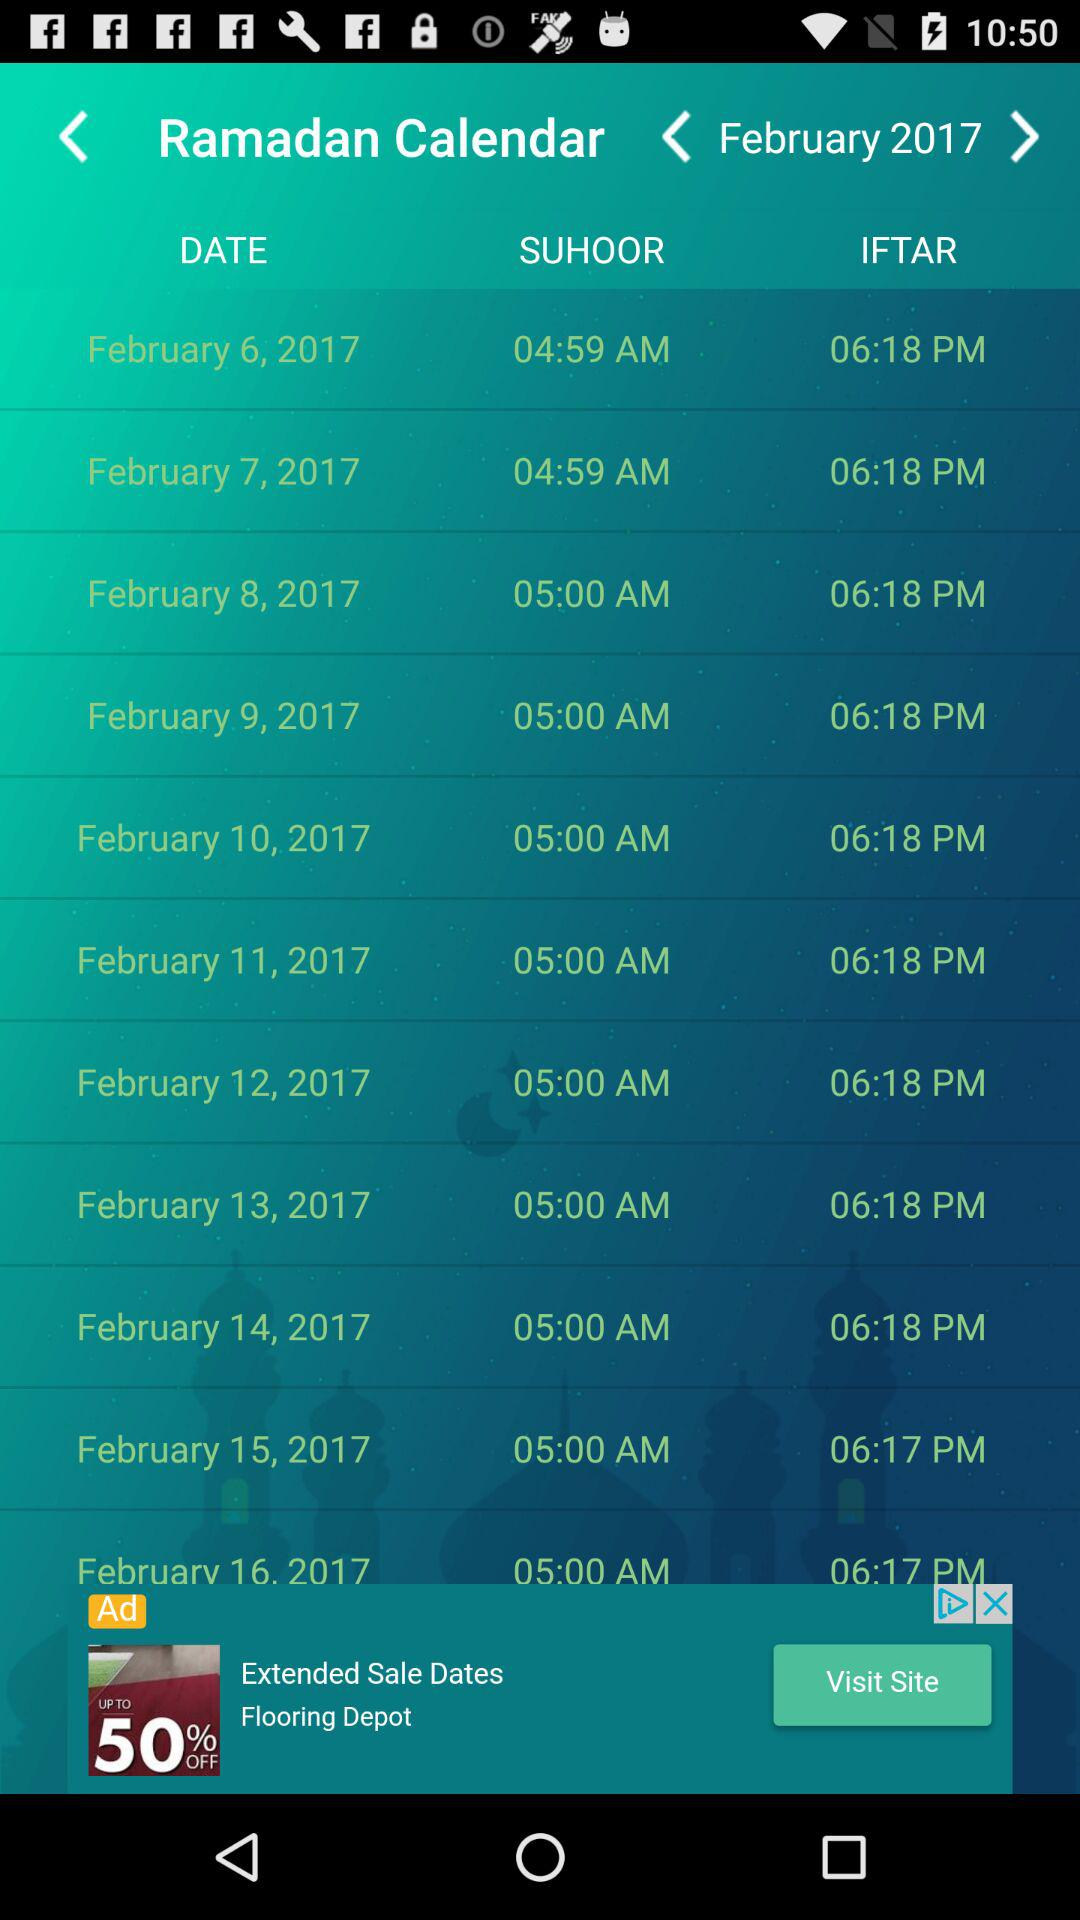On which date can we do iftar at 06:17 PM? You can do iftar at 06:17 PM on February 15 and February 16, 2017. 